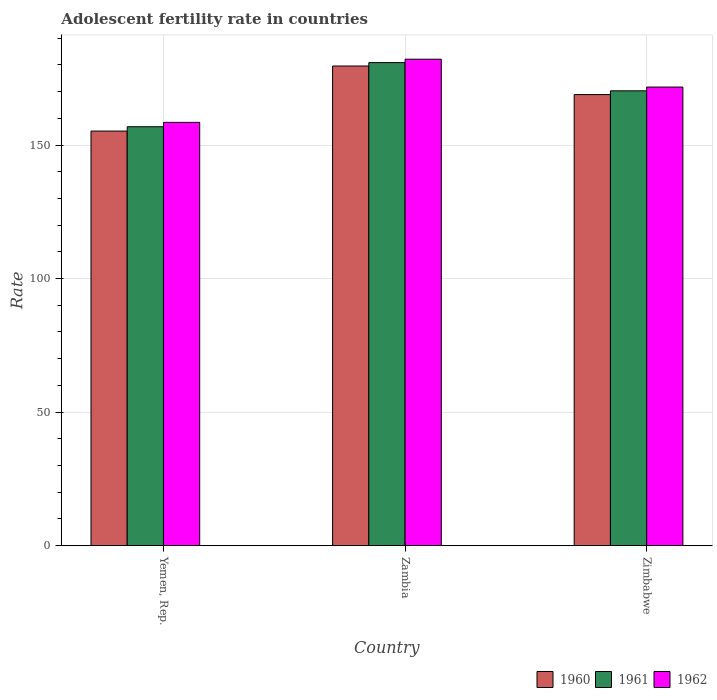How many different coloured bars are there?
Your response must be concise. 3. How many bars are there on the 2nd tick from the right?
Offer a terse response. 3. What is the label of the 2nd group of bars from the left?
Offer a terse response. Zambia. What is the adolescent fertility rate in 1962 in Yemen, Rep.?
Your answer should be compact. 158.48. Across all countries, what is the maximum adolescent fertility rate in 1960?
Provide a succinct answer. 179.58. Across all countries, what is the minimum adolescent fertility rate in 1962?
Make the answer very short. 158.48. In which country was the adolescent fertility rate in 1961 maximum?
Your answer should be compact. Zambia. In which country was the adolescent fertility rate in 1961 minimum?
Your answer should be compact. Yemen, Rep. What is the total adolescent fertility rate in 1961 in the graph?
Offer a very short reply. 507.98. What is the difference between the adolescent fertility rate in 1962 in Zambia and that in Zimbabwe?
Give a very brief answer. 10.43. What is the difference between the adolescent fertility rate in 1961 in Yemen, Rep. and the adolescent fertility rate in 1962 in Zambia?
Make the answer very short. -25.28. What is the average adolescent fertility rate in 1960 per country?
Make the answer very short. 167.89. What is the difference between the adolescent fertility rate of/in 1961 and adolescent fertility rate of/in 1960 in Zambia?
Offer a very short reply. 1.27. In how many countries, is the adolescent fertility rate in 1961 greater than 80?
Your answer should be compact. 3. What is the ratio of the adolescent fertility rate in 1960 in Yemen, Rep. to that in Zambia?
Make the answer very short. 0.86. Is the adolescent fertility rate in 1962 in Zambia less than that in Zimbabwe?
Give a very brief answer. No. Is the difference between the adolescent fertility rate in 1961 in Yemen, Rep. and Zambia greater than the difference between the adolescent fertility rate in 1960 in Yemen, Rep. and Zambia?
Provide a short and direct response. Yes. What is the difference between the highest and the second highest adolescent fertility rate in 1961?
Give a very brief answer. -13.44. What is the difference between the highest and the lowest adolescent fertility rate in 1960?
Make the answer very short. 24.36. What does the 2nd bar from the left in Zimbabwe represents?
Provide a short and direct response. 1961. How many bars are there?
Offer a terse response. 9. How many countries are there in the graph?
Your response must be concise. 3. What is the difference between two consecutive major ticks on the Y-axis?
Ensure brevity in your answer.  50. Are the values on the major ticks of Y-axis written in scientific E-notation?
Give a very brief answer. No. Where does the legend appear in the graph?
Give a very brief answer. Bottom right. What is the title of the graph?
Provide a short and direct response. Adolescent fertility rate in countries. Does "1965" appear as one of the legend labels in the graph?
Your answer should be compact. No. What is the label or title of the Y-axis?
Give a very brief answer. Rate. What is the Rate in 1960 in Yemen, Rep.?
Offer a very short reply. 155.21. What is the Rate of 1961 in Yemen, Rep.?
Offer a terse response. 156.85. What is the Rate of 1962 in Yemen, Rep.?
Ensure brevity in your answer.  158.48. What is the Rate in 1960 in Zambia?
Keep it short and to the point. 179.58. What is the Rate in 1961 in Zambia?
Give a very brief answer. 180.85. What is the Rate of 1962 in Zambia?
Provide a short and direct response. 182.12. What is the Rate of 1960 in Zimbabwe?
Offer a terse response. 168.87. What is the Rate of 1961 in Zimbabwe?
Make the answer very short. 170.28. What is the Rate of 1962 in Zimbabwe?
Your answer should be very brief. 171.7. Across all countries, what is the maximum Rate in 1960?
Give a very brief answer. 179.58. Across all countries, what is the maximum Rate in 1961?
Keep it short and to the point. 180.85. Across all countries, what is the maximum Rate of 1962?
Keep it short and to the point. 182.12. Across all countries, what is the minimum Rate of 1960?
Provide a succinct answer. 155.21. Across all countries, what is the minimum Rate of 1961?
Your answer should be compact. 156.85. Across all countries, what is the minimum Rate of 1962?
Your answer should be compact. 158.48. What is the total Rate in 1960 in the graph?
Give a very brief answer. 503.66. What is the total Rate in 1961 in the graph?
Provide a succinct answer. 507.98. What is the total Rate of 1962 in the graph?
Ensure brevity in your answer.  512.29. What is the difference between the Rate in 1960 in Yemen, Rep. and that in Zambia?
Offer a very short reply. -24.36. What is the difference between the Rate in 1961 in Yemen, Rep. and that in Zambia?
Offer a terse response. -24. What is the difference between the Rate of 1962 in Yemen, Rep. and that in Zambia?
Your answer should be compact. -23.65. What is the difference between the Rate in 1960 in Yemen, Rep. and that in Zimbabwe?
Keep it short and to the point. -13.66. What is the difference between the Rate of 1961 in Yemen, Rep. and that in Zimbabwe?
Make the answer very short. -13.44. What is the difference between the Rate in 1962 in Yemen, Rep. and that in Zimbabwe?
Offer a very short reply. -13.22. What is the difference between the Rate of 1960 in Zambia and that in Zimbabwe?
Your answer should be compact. 10.7. What is the difference between the Rate in 1961 in Zambia and that in Zimbabwe?
Your response must be concise. 10.56. What is the difference between the Rate of 1962 in Zambia and that in Zimbabwe?
Offer a very short reply. 10.43. What is the difference between the Rate of 1960 in Yemen, Rep. and the Rate of 1961 in Zambia?
Provide a succinct answer. -25.64. What is the difference between the Rate in 1960 in Yemen, Rep. and the Rate in 1962 in Zambia?
Ensure brevity in your answer.  -26.91. What is the difference between the Rate of 1961 in Yemen, Rep. and the Rate of 1962 in Zambia?
Provide a short and direct response. -25.28. What is the difference between the Rate in 1960 in Yemen, Rep. and the Rate in 1961 in Zimbabwe?
Offer a very short reply. -15.07. What is the difference between the Rate in 1960 in Yemen, Rep. and the Rate in 1962 in Zimbabwe?
Provide a short and direct response. -16.48. What is the difference between the Rate in 1961 in Yemen, Rep. and the Rate in 1962 in Zimbabwe?
Provide a short and direct response. -14.85. What is the difference between the Rate of 1960 in Zambia and the Rate of 1961 in Zimbabwe?
Ensure brevity in your answer.  9.29. What is the difference between the Rate of 1960 in Zambia and the Rate of 1962 in Zimbabwe?
Offer a terse response. 7.88. What is the difference between the Rate of 1961 in Zambia and the Rate of 1962 in Zimbabwe?
Provide a succinct answer. 9.15. What is the average Rate of 1960 per country?
Ensure brevity in your answer.  167.89. What is the average Rate of 1961 per country?
Your answer should be compact. 169.33. What is the average Rate of 1962 per country?
Make the answer very short. 170.76. What is the difference between the Rate of 1960 and Rate of 1961 in Yemen, Rep.?
Provide a short and direct response. -1.63. What is the difference between the Rate in 1960 and Rate in 1962 in Yemen, Rep.?
Your response must be concise. -3.26. What is the difference between the Rate of 1961 and Rate of 1962 in Yemen, Rep.?
Make the answer very short. -1.63. What is the difference between the Rate of 1960 and Rate of 1961 in Zambia?
Your response must be concise. -1.27. What is the difference between the Rate of 1960 and Rate of 1962 in Zambia?
Offer a very short reply. -2.55. What is the difference between the Rate of 1961 and Rate of 1962 in Zambia?
Your answer should be compact. -1.27. What is the difference between the Rate of 1960 and Rate of 1961 in Zimbabwe?
Your answer should be compact. -1.41. What is the difference between the Rate of 1960 and Rate of 1962 in Zimbabwe?
Your response must be concise. -2.82. What is the difference between the Rate of 1961 and Rate of 1962 in Zimbabwe?
Your response must be concise. -1.41. What is the ratio of the Rate in 1960 in Yemen, Rep. to that in Zambia?
Your answer should be very brief. 0.86. What is the ratio of the Rate of 1961 in Yemen, Rep. to that in Zambia?
Give a very brief answer. 0.87. What is the ratio of the Rate in 1962 in Yemen, Rep. to that in Zambia?
Offer a terse response. 0.87. What is the ratio of the Rate of 1960 in Yemen, Rep. to that in Zimbabwe?
Your answer should be compact. 0.92. What is the ratio of the Rate of 1961 in Yemen, Rep. to that in Zimbabwe?
Your answer should be compact. 0.92. What is the ratio of the Rate of 1962 in Yemen, Rep. to that in Zimbabwe?
Offer a terse response. 0.92. What is the ratio of the Rate of 1960 in Zambia to that in Zimbabwe?
Provide a succinct answer. 1.06. What is the ratio of the Rate in 1961 in Zambia to that in Zimbabwe?
Provide a short and direct response. 1.06. What is the ratio of the Rate of 1962 in Zambia to that in Zimbabwe?
Give a very brief answer. 1.06. What is the difference between the highest and the second highest Rate in 1960?
Provide a short and direct response. 10.7. What is the difference between the highest and the second highest Rate in 1961?
Provide a succinct answer. 10.56. What is the difference between the highest and the second highest Rate of 1962?
Provide a succinct answer. 10.43. What is the difference between the highest and the lowest Rate in 1960?
Offer a very short reply. 24.36. What is the difference between the highest and the lowest Rate of 1961?
Offer a very short reply. 24. What is the difference between the highest and the lowest Rate of 1962?
Offer a very short reply. 23.65. 